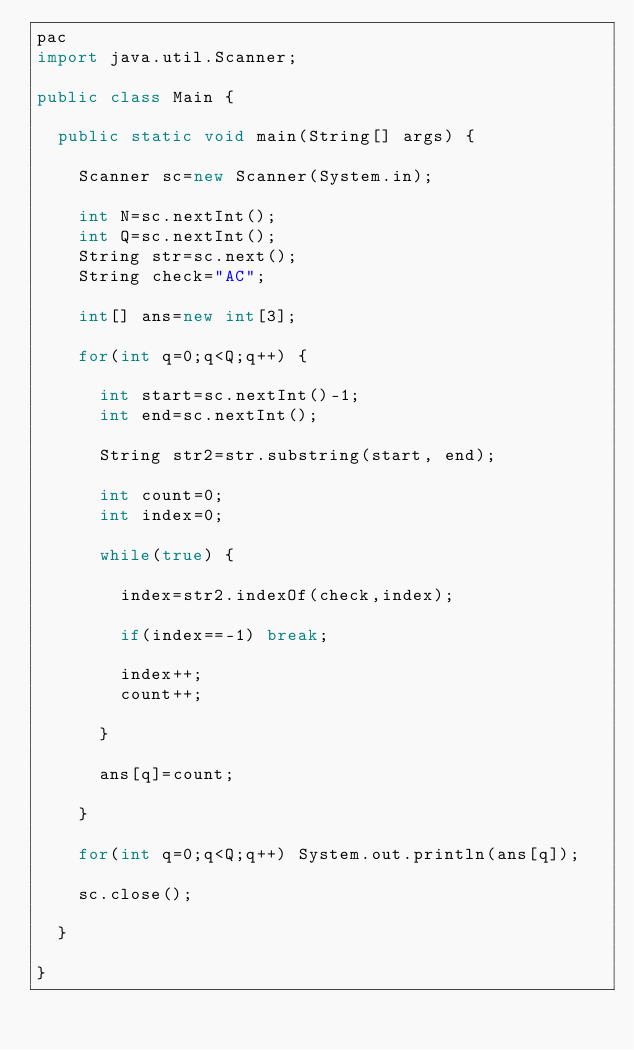Convert code to text. <code><loc_0><loc_0><loc_500><loc_500><_Java_>pac
import java.util.Scanner;

public class Main {

	public static void main(String[] args) {

		Scanner sc=new Scanner(System.in);

		int N=sc.nextInt();
		int Q=sc.nextInt();
		String str=sc.next();
		String check="AC";

		int[] ans=new int[3];

		for(int q=0;q<Q;q++) {

			int start=sc.nextInt()-1;
			int end=sc.nextInt();

			String str2=str.substring(start, end);

			int count=0;
			int index=0;

			while(true) {

				index=str2.indexOf(check,index);

				if(index==-1) break;

				index++;
				count++;

			}

			ans[q]=count;

		}

		for(int q=0;q<Q;q++) System.out.println(ans[q]);

		sc.close();

	}

}
</code> 